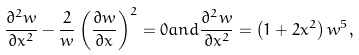<formula> <loc_0><loc_0><loc_500><loc_500>\frac { \partial ^ { 2 } w } { \partial x ^ { 2 } } - \frac { 2 } { w } \left ( \frac { \partial w } { \partial x } \right ) ^ { 2 } = 0 a n d \frac { \partial ^ { 2 } w } { \partial x ^ { 2 } } = \left ( 1 + 2 x ^ { 2 } \right ) w ^ { 5 } ,</formula> 